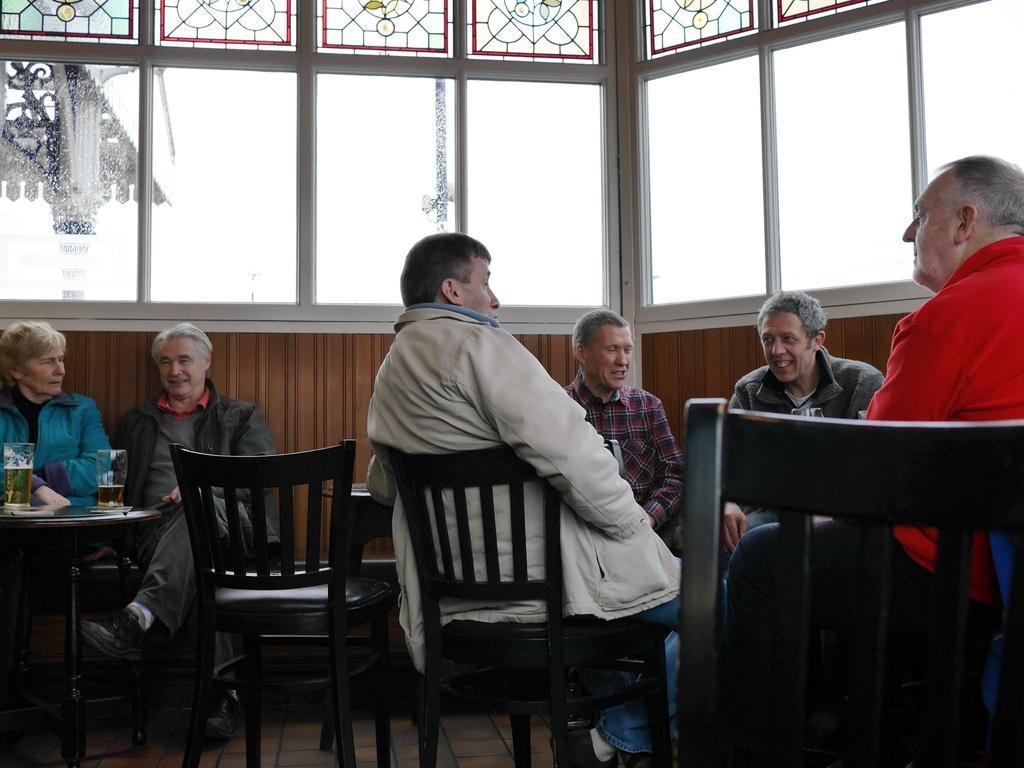Describe this image in one or two sentences. There are few people sitting on the chairs. This is a table with tumblers of alcohol in it. These are the windows. I can see a pillar through the window. 